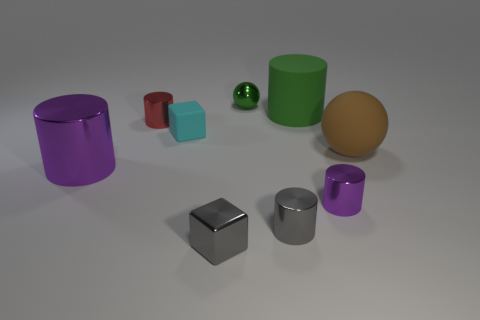Describe the texture and color of the object farthest to the left. The object farthest to the left is a purple cylinder with a glossy finish. Its color is a deep shade of purple that reflects the light, creating highlights and subtle reflections on its surface. 